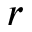<formula> <loc_0><loc_0><loc_500><loc_500>r</formula> 